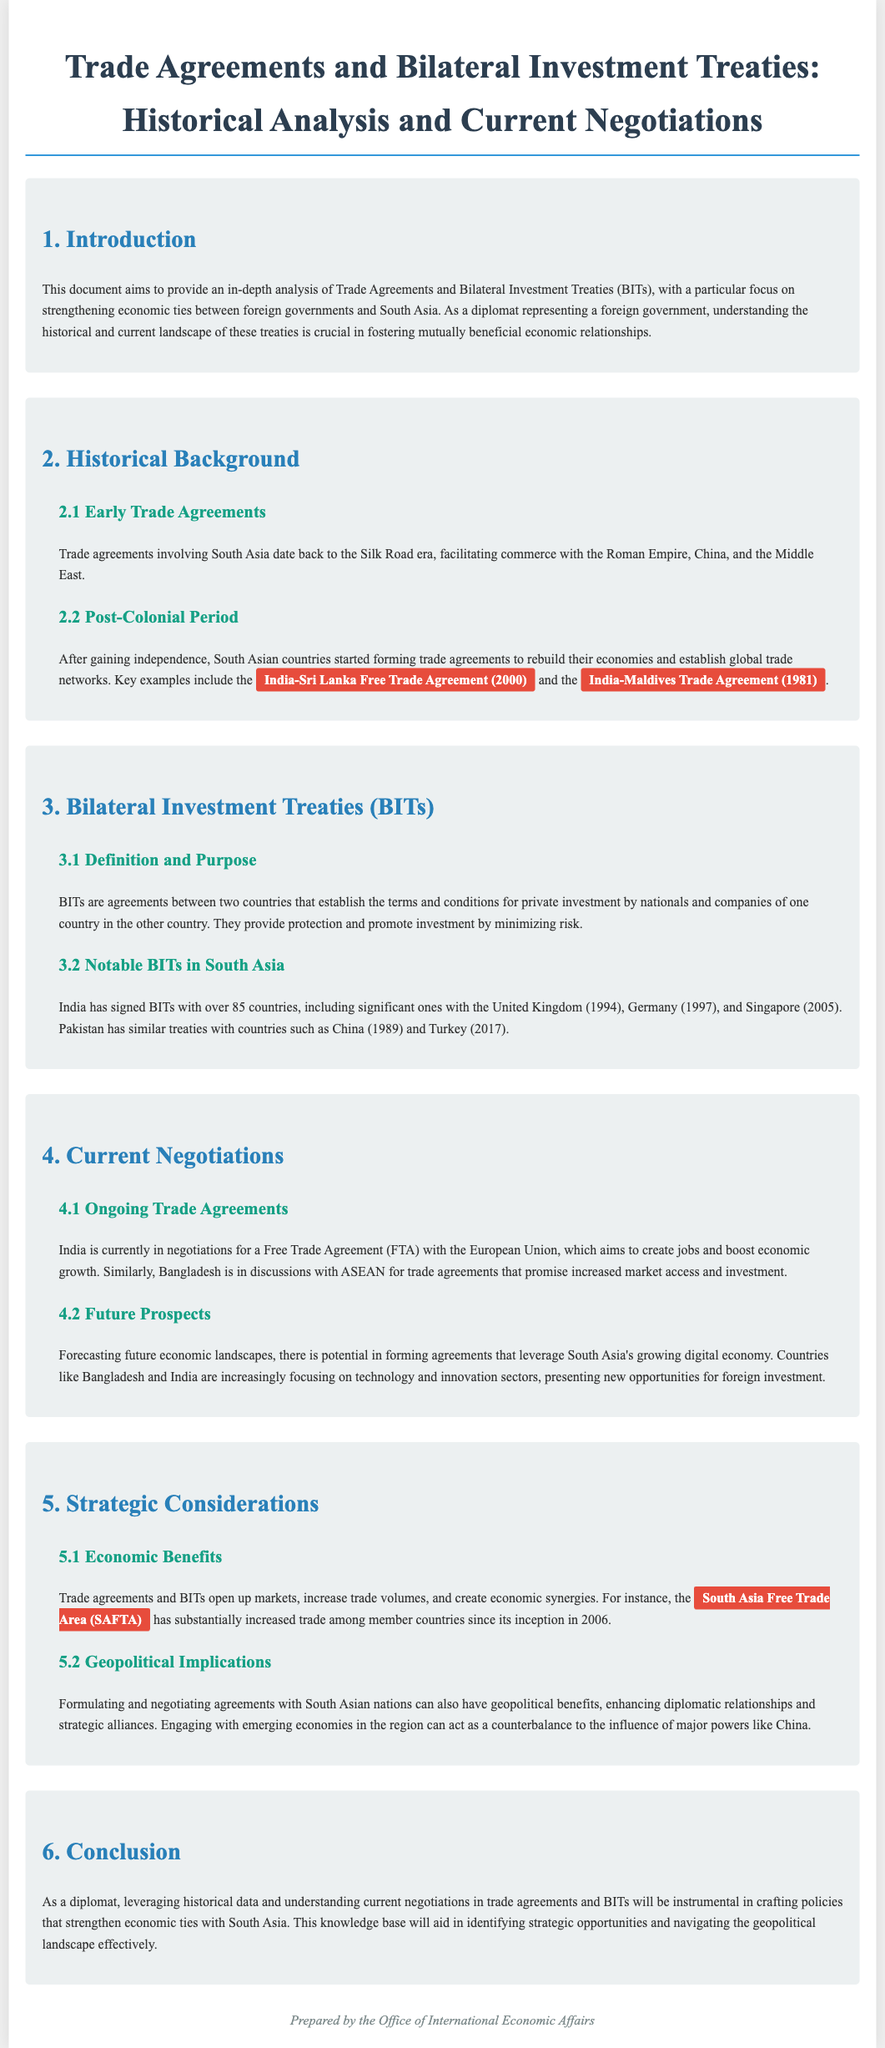What is the title of the document? The title is the first major heading in the document, which identifies its purpose.
Answer: Trade Agreements and Bilateral Investment Treaties: Historical Analysis and Current Negotiations What year was the India-Sri Lanka Free Trade Agreement signed? The date can be found in the historical section discussing post-colonial trade agreements.
Answer: 2000 What type of agreement is a BIT? The document defines this in the section about Bilateral Investment Treaties, explaining its nature.
Answer: Agreement What are the notable BITs mentioned in the document? This refers to the examples listed in the subsection about notable BITs in South Asia.
Answer: United Kingdom, Germany, Singapore, China, Turkey How many countries has India signed BITs with? The number is explicitly stated in the document, providing insight into India's engagement with foreign investments.
Answer: Over 85 What is the primary focus of India's current negotiations with the European Union? This is a key aspect discussed in the current negotiations section, revealing the goals of the ongoing trade discussions.
Answer: Create jobs and boost economic growth What does the South Asia Free Trade Area (SAFTA) aim to do? The document specifies the objectives of SAFTA within the section discussing economic benefits.
Answer: Increase trade among member countries What region is increasingly focusing on technology and innovation sectors? This pertains to the future prospects of trade and investment as outlined in the document.
Answer: South Asia What can engaging with South Asian nations enhance? The document mentions strategic aspects regarding geopolitical relations in the context of trade agreements.
Answer: Diplomatic relationships and strategic alliances 